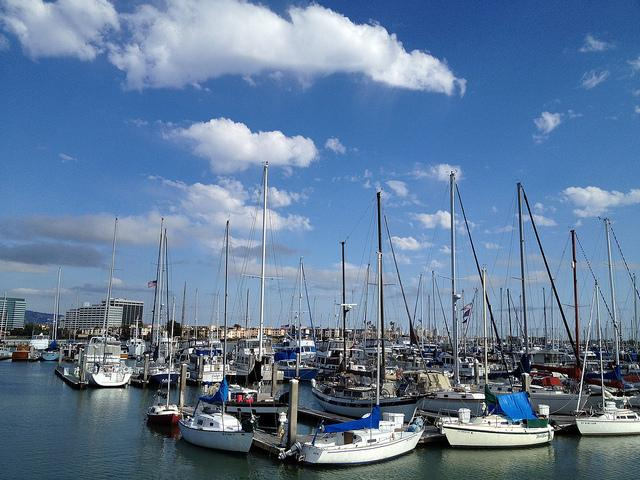Which object on one of the boats would help someone prepare for rain? Please explain your reasoning. tarp. Some of the boats have leaks and are covered. 